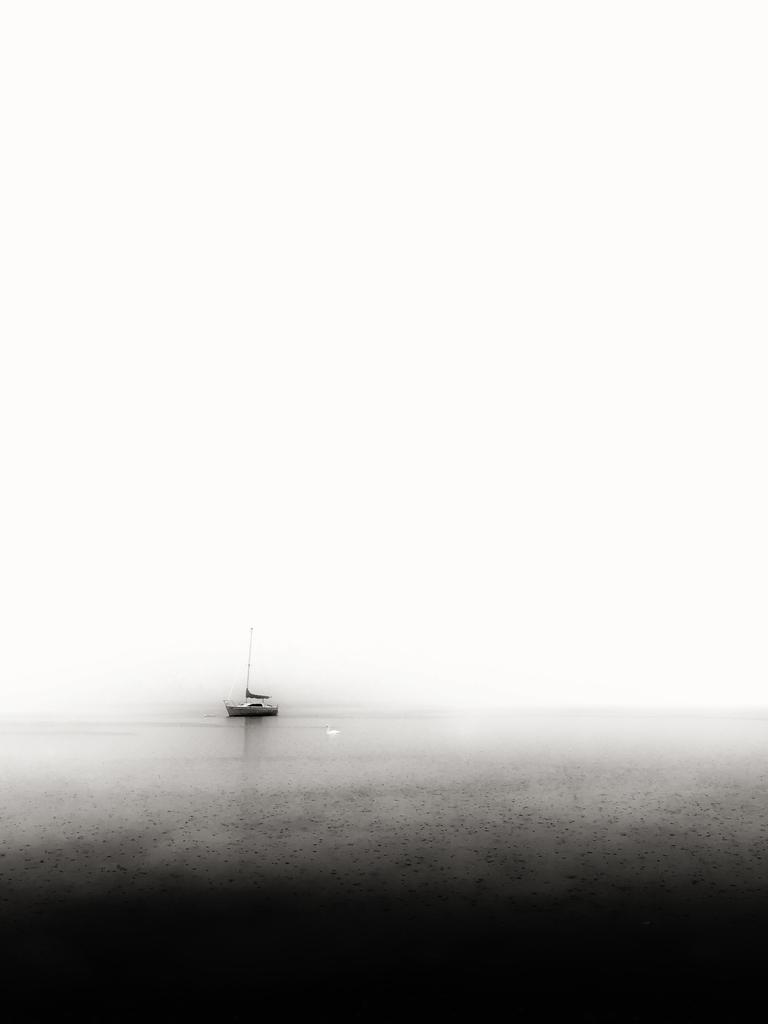What is the main subject in the image? There is a boat in the image. Where is the boat located? The boat is on the surface of the water. How close is the boat to the viewer? The boat is in the foreground of the image. What date is circled on the calendar in the image? There is no calendar present in the image, so it is not possible to answer that question. 